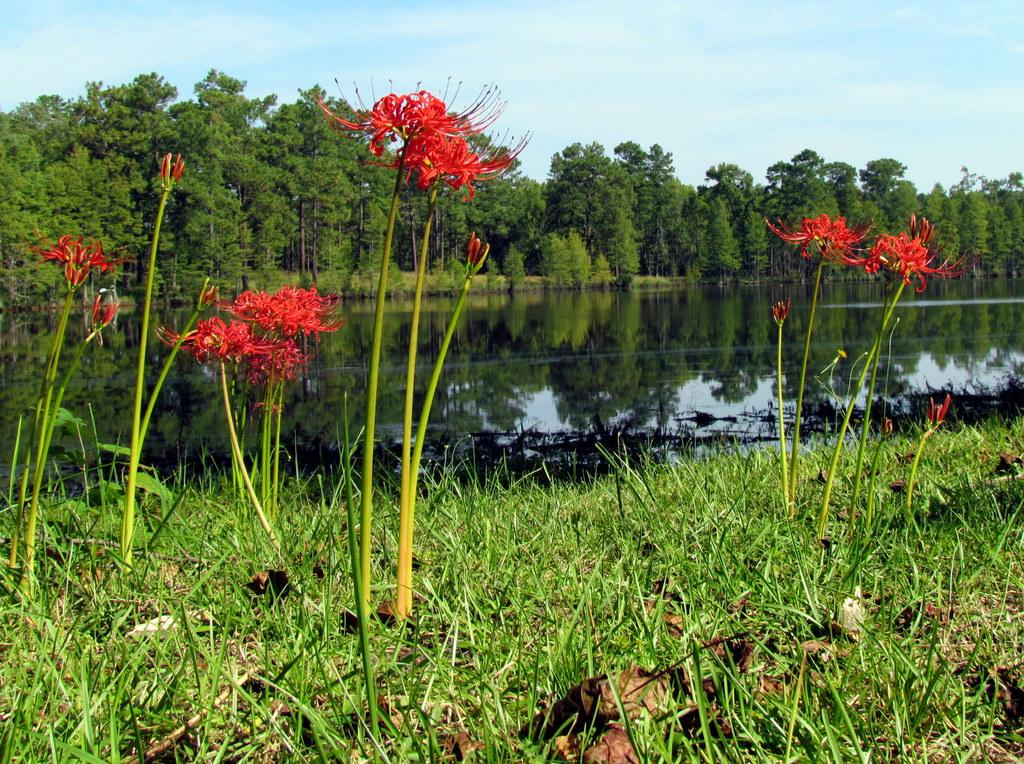What type of vegetation can be seen in the image? There is grass and plants with flowers in the image. What else can be seen in the image besides vegetation? There is water visible in the image. What other natural elements are present in the image? There are trees in the image. What is visible in the background of the image? The sky is visible in the background of the image. What type of straw is being used to make noise in the image? There is no straw or noise present in the image; it features natural elements such as grass, plants, water, trees, and the sky. 